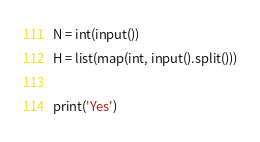<code> <loc_0><loc_0><loc_500><loc_500><_Python_>N = int(input())
H = list(map(int, input().split()))

print('Yes')</code> 